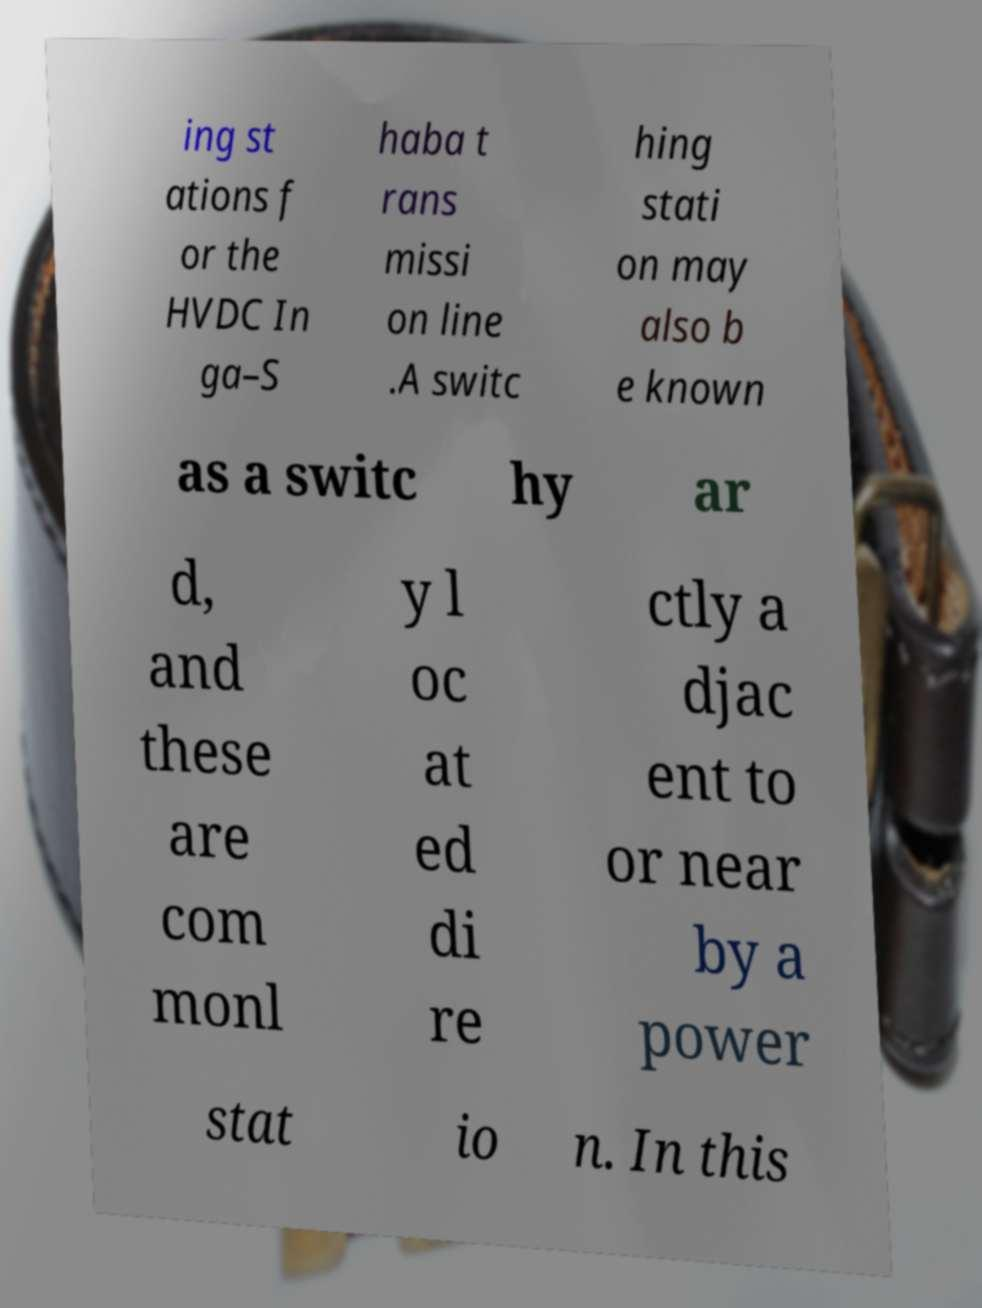What messages or text are displayed in this image? I need them in a readable, typed format. ing st ations f or the HVDC In ga–S haba t rans missi on line .A switc hing stati on may also b e known as a switc hy ar d, and these are com monl y l oc at ed di re ctly a djac ent to or near by a power stat io n. In this 